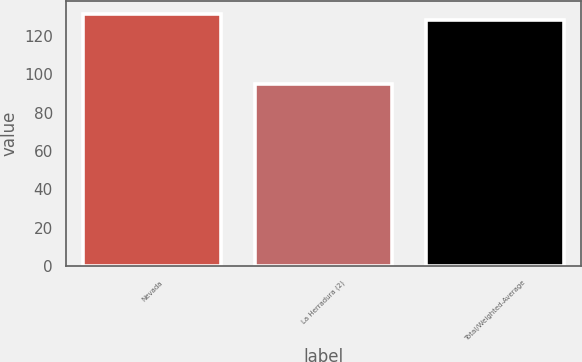<chart> <loc_0><loc_0><loc_500><loc_500><bar_chart><fcel>Nevada<fcel>La Herradura (2)<fcel>Total/Weighted-Average<nl><fcel>131.5<fcel>95<fcel>128<nl></chart> 